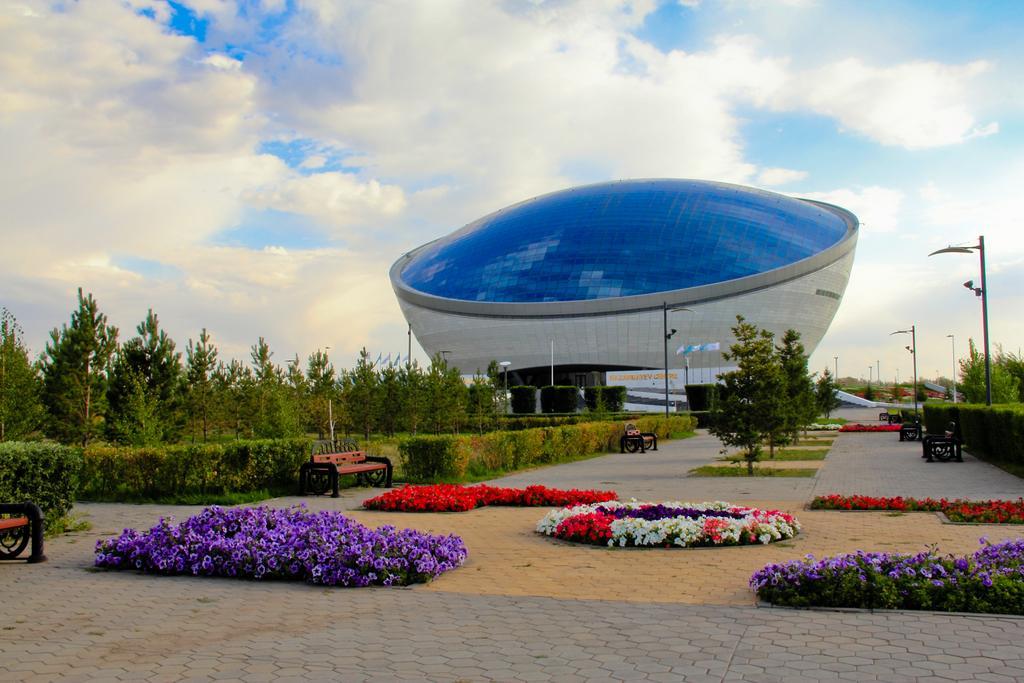Please provide a concise description of this image. As we can see in the image there are flowers, benches, plants, current poles and trees. At the top there is sky and clouds. 